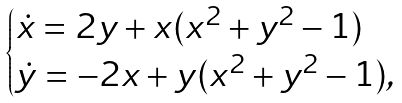<formula> <loc_0><loc_0><loc_500><loc_500>\begin{cases} \dot { x } = 2 y + x ( x ^ { 2 } + y ^ { 2 } - 1 ) \\ \dot { y } = - 2 x + y ( x ^ { 2 } + y ^ { 2 } - 1 ) , \end{cases}</formula> 